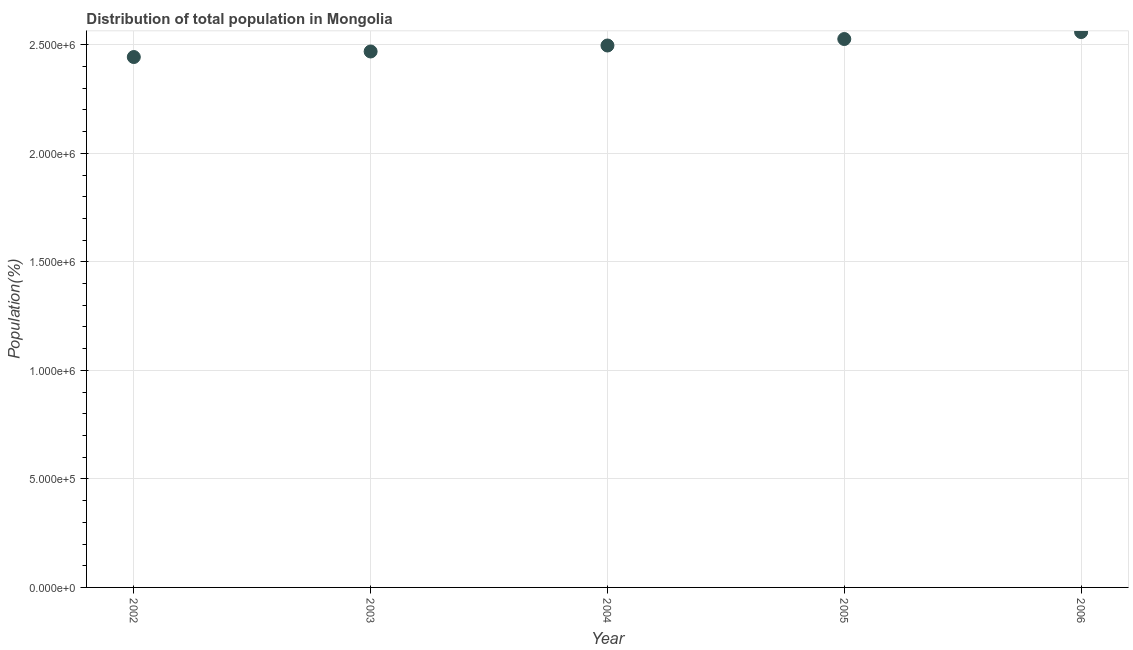What is the population in 2002?
Give a very brief answer. 2.44e+06. Across all years, what is the maximum population?
Your answer should be very brief. 2.56e+06. Across all years, what is the minimum population?
Offer a terse response. 2.44e+06. What is the sum of the population?
Provide a short and direct response. 1.25e+07. What is the difference between the population in 2002 and 2004?
Make the answer very short. -5.31e+04. What is the average population per year?
Your answer should be compact. 2.50e+06. What is the median population?
Provide a short and direct response. 2.50e+06. In how many years, is the population greater than 600000 %?
Ensure brevity in your answer.  5. Do a majority of the years between 2004 and 2002 (inclusive) have population greater than 200000 %?
Offer a terse response. No. What is the ratio of the population in 2003 to that in 2005?
Provide a short and direct response. 0.98. Is the population in 2003 less than that in 2004?
Your answer should be compact. Yes. Is the difference between the population in 2002 and 2004 greater than the difference between any two years?
Make the answer very short. No. What is the difference between the highest and the second highest population?
Provide a succinct answer. 3.20e+04. What is the difference between the highest and the lowest population?
Offer a terse response. 1.15e+05. What is the difference between two consecutive major ticks on the Y-axis?
Your answer should be compact. 5.00e+05. Are the values on the major ticks of Y-axis written in scientific E-notation?
Your response must be concise. Yes. Does the graph contain any zero values?
Provide a short and direct response. No. Does the graph contain grids?
Your response must be concise. Yes. What is the title of the graph?
Provide a short and direct response. Distribution of total population in Mongolia . What is the label or title of the Y-axis?
Provide a succinct answer. Population(%). What is the Population(%) in 2002?
Give a very brief answer. 2.44e+06. What is the Population(%) in 2003?
Ensure brevity in your answer.  2.47e+06. What is the Population(%) in 2004?
Offer a terse response. 2.50e+06. What is the Population(%) in 2005?
Ensure brevity in your answer.  2.53e+06. What is the Population(%) in 2006?
Provide a short and direct response. 2.56e+06. What is the difference between the Population(%) in 2002 and 2003?
Ensure brevity in your answer.  -2.55e+04. What is the difference between the Population(%) in 2002 and 2004?
Keep it short and to the point. -5.31e+04. What is the difference between the Population(%) in 2002 and 2005?
Offer a terse response. -8.29e+04. What is the difference between the Population(%) in 2002 and 2006?
Offer a terse response. -1.15e+05. What is the difference between the Population(%) in 2003 and 2004?
Give a very brief answer. -2.76e+04. What is the difference between the Population(%) in 2003 and 2005?
Provide a short and direct response. -5.74e+04. What is the difference between the Population(%) in 2003 and 2006?
Provide a succinct answer. -8.94e+04. What is the difference between the Population(%) in 2004 and 2005?
Ensure brevity in your answer.  -2.98e+04. What is the difference between the Population(%) in 2004 and 2006?
Your answer should be compact. -6.19e+04. What is the difference between the Population(%) in 2005 and 2006?
Your answer should be compact. -3.20e+04. What is the ratio of the Population(%) in 2002 to that in 2006?
Provide a short and direct response. 0.95. What is the ratio of the Population(%) in 2003 to that in 2006?
Provide a short and direct response. 0.96. What is the ratio of the Population(%) in 2005 to that in 2006?
Provide a succinct answer. 0.99. 